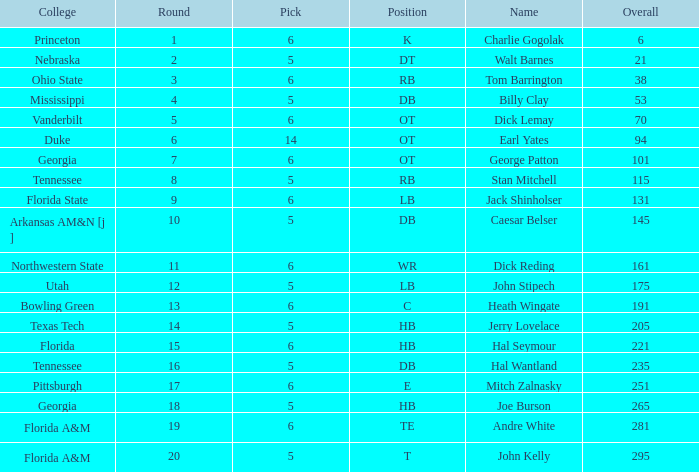What is Pick, when Round is 15? 6.0. I'm looking to parse the entire table for insights. Could you assist me with that? {'header': ['College', 'Round', 'Pick', 'Position', 'Name', 'Overall'], 'rows': [['Princeton', '1', '6', 'K', 'Charlie Gogolak', '6'], ['Nebraska', '2', '5', 'DT', 'Walt Barnes', '21'], ['Ohio State', '3', '6', 'RB', 'Tom Barrington', '38'], ['Mississippi', '4', '5', 'DB', 'Billy Clay', '53'], ['Vanderbilt', '5', '6', 'OT', 'Dick Lemay', '70'], ['Duke', '6', '14', 'OT', 'Earl Yates', '94'], ['Georgia', '7', '6', 'OT', 'George Patton', '101'], ['Tennessee', '8', '5', 'RB', 'Stan Mitchell', '115'], ['Florida State', '9', '6', 'LB', 'Jack Shinholser', '131'], ['Arkansas AM&N [j ]', '10', '5', 'DB', 'Caesar Belser', '145'], ['Northwestern State', '11', '6', 'WR', 'Dick Reding', '161'], ['Utah', '12', '5', 'LB', 'John Stipech', '175'], ['Bowling Green', '13', '6', 'C', 'Heath Wingate', '191'], ['Texas Tech', '14', '5', 'HB', 'Jerry Lovelace', '205'], ['Florida', '15', '6', 'HB', 'Hal Seymour', '221'], ['Tennessee', '16', '5', 'DB', 'Hal Wantland', '235'], ['Pittsburgh', '17', '6', 'E', 'Mitch Zalnasky', '251'], ['Georgia', '18', '5', 'HB', 'Joe Burson', '265'], ['Florida A&M', '19', '6', 'TE', 'Andre White', '281'], ['Florida A&M', '20', '5', 'T', 'John Kelly', '295']]} 